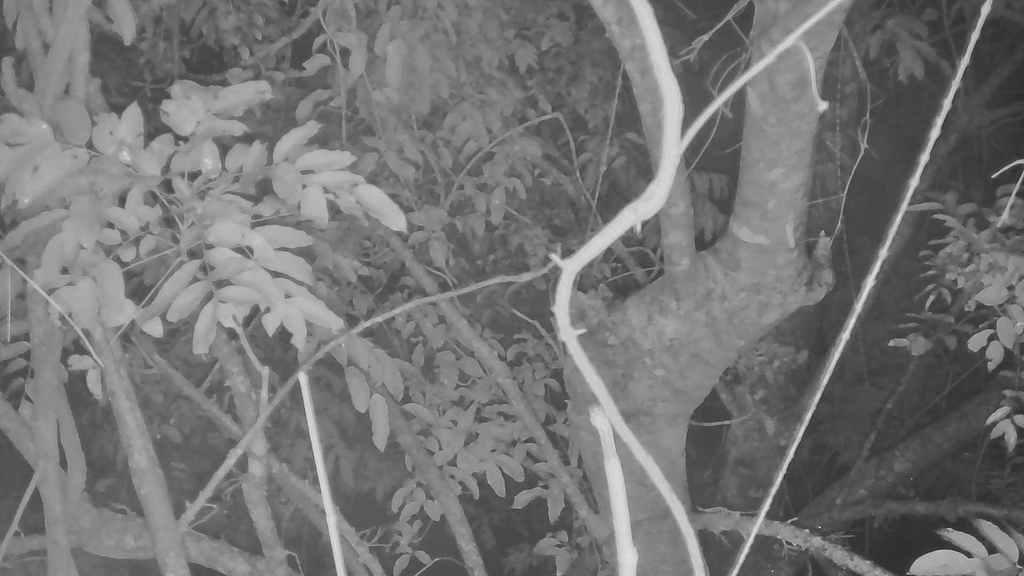In one or two sentences, can you explain what this image depicts? This image is a black and white image. This image is taken outdoors. In this image there are a few trees and plants. 